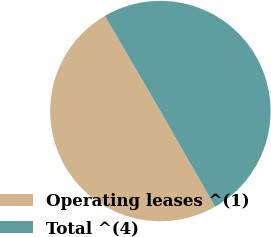Convert chart. <chart><loc_0><loc_0><loc_500><loc_500><pie_chart><fcel>Operating leases ^(1)<fcel>Total ^(4)<nl><fcel>49.87%<fcel>50.13%<nl></chart> 